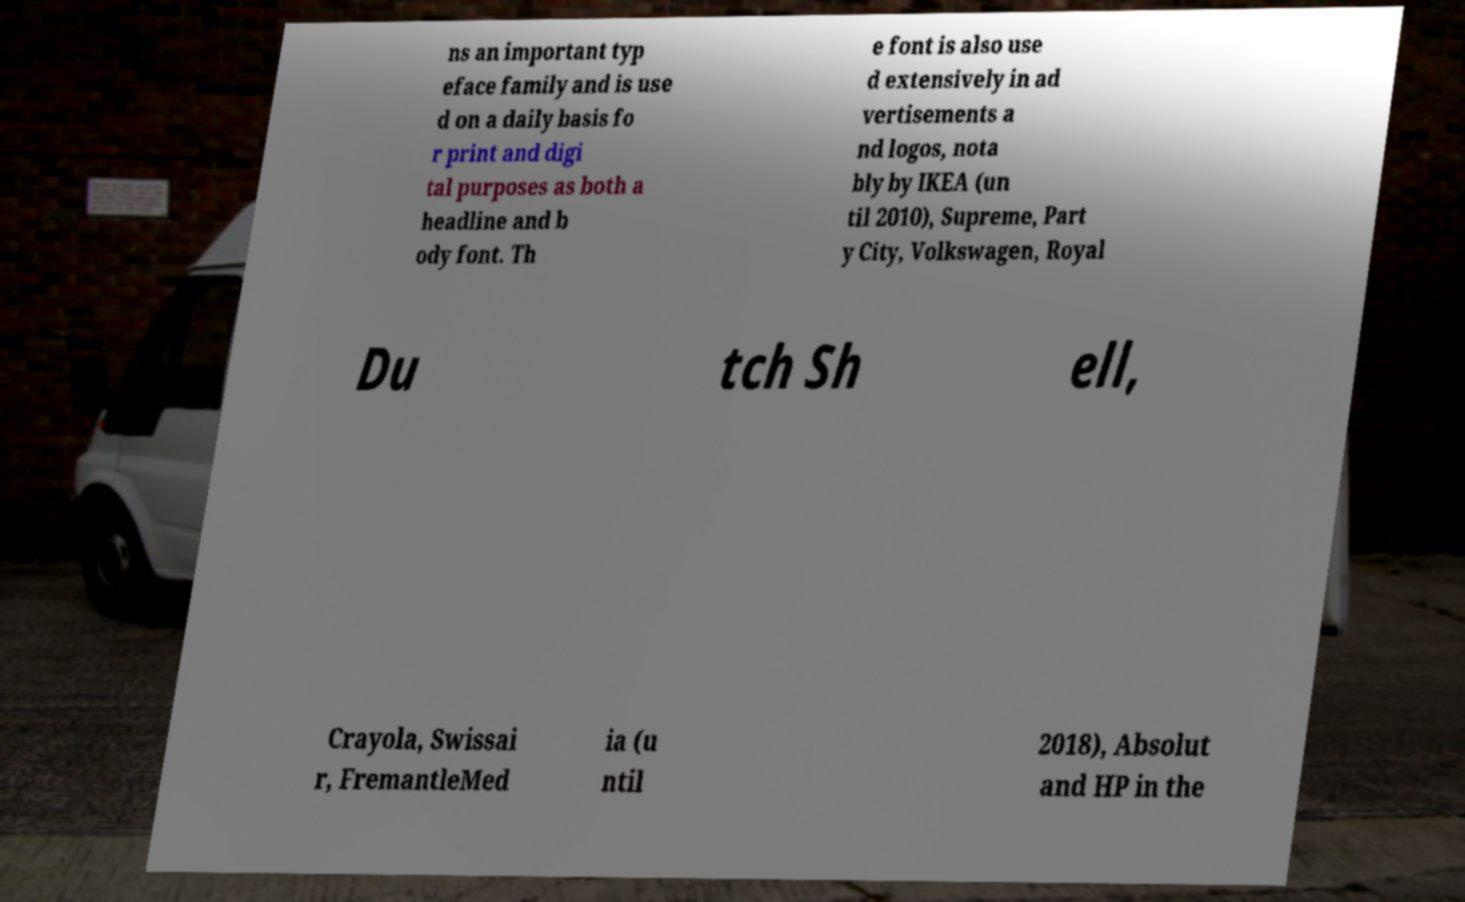Can you accurately transcribe the text from the provided image for me? ns an important typ eface family and is use d on a daily basis fo r print and digi tal purposes as both a headline and b ody font. Th e font is also use d extensively in ad vertisements a nd logos, nota bly by IKEA (un til 2010), Supreme, Part y City, Volkswagen, Royal Du tch Sh ell, Crayola, Swissai r, FremantleMed ia (u ntil 2018), Absolut and HP in the 